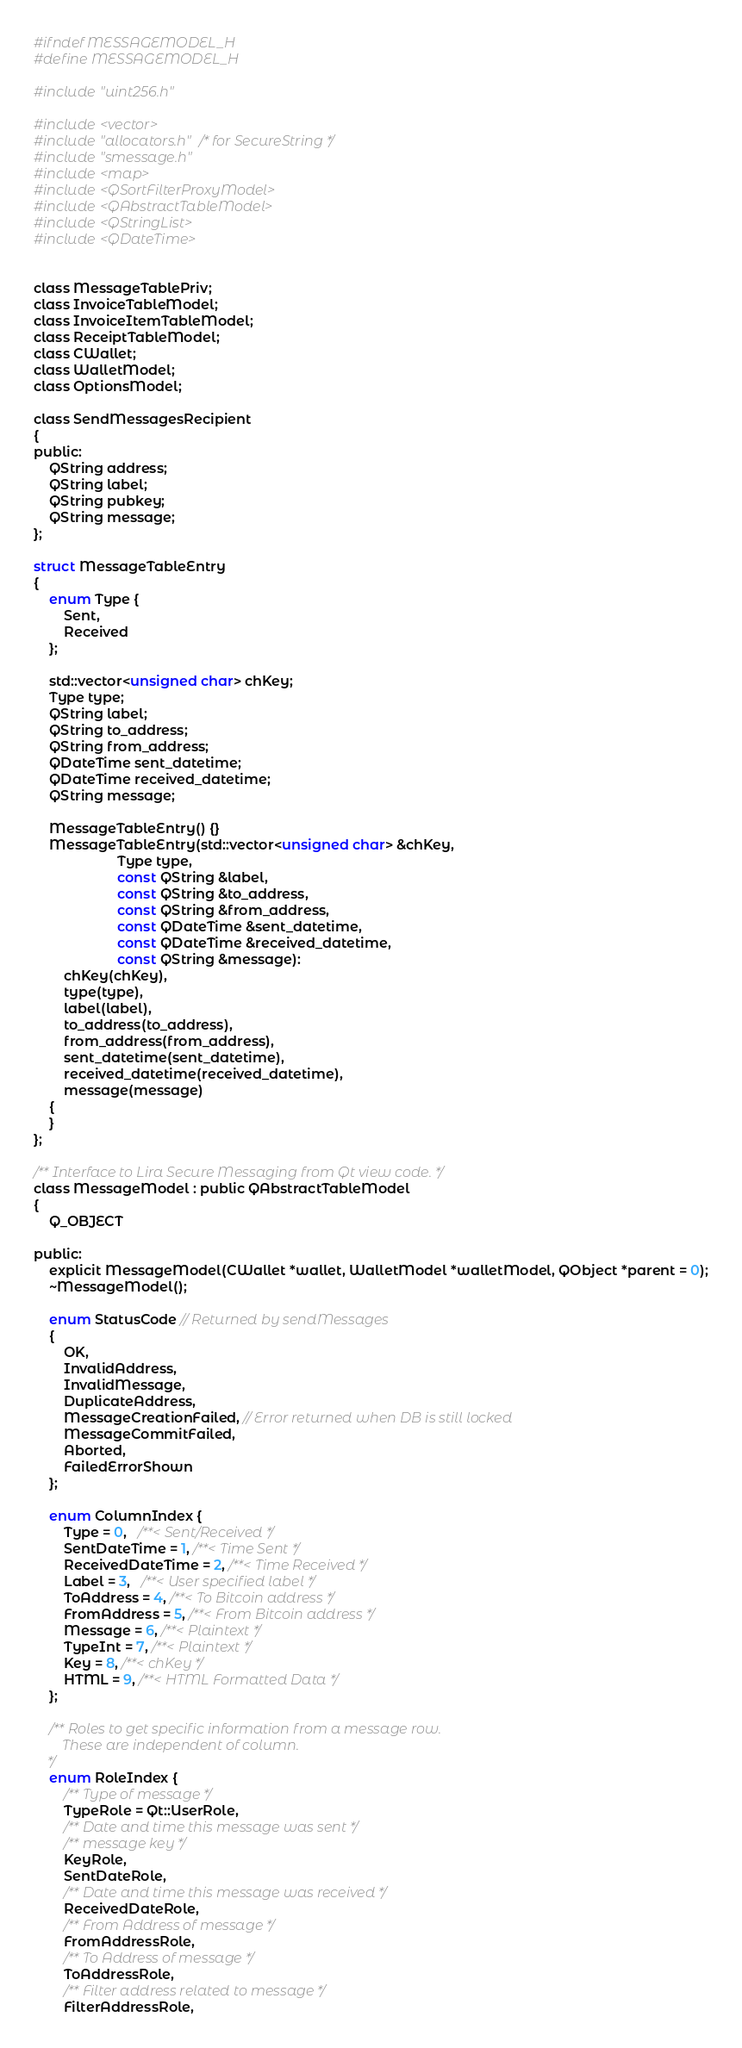Convert code to text. <code><loc_0><loc_0><loc_500><loc_500><_C_>#ifndef MESSAGEMODEL_H
#define MESSAGEMODEL_H

#include "uint256.h"

#include <vector>
#include "allocators.h" /* for SecureString */
#include "smessage.h"
#include <map>
#include <QSortFilterProxyModel>
#include <QAbstractTableModel>
#include <QStringList>
#include <QDateTime>


class MessageTablePriv;
class InvoiceTableModel;
class InvoiceItemTableModel;
class ReceiptTableModel;
class CWallet;
class WalletModel;
class OptionsModel;

class SendMessagesRecipient
{
public:
    QString address;
    QString label;
    QString pubkey;
    QString message;
};

struct MessageTableEntry
{
    enum Type {
        Sent,
        Received
    };
    
    std::vector<unsigned char> chKey;
    Type type;
    QString label;
    QString to_address;
    QString from_address;
    QDateTime sent_datetime;
    QDateTime received_datetime;
    QString message;

    MessageTableEntry() {}
    MessageTableEntry(std::vector<unsigned char> &chKey,
                      Type type,
                      const QString &label,
                      const QString &to_address,
                      const QString &from_address,
                      const QDateTime &sent_datetime,
                      const QDateTime &received_datetime,
                      const QString &message):
        chKey(chKey),
        type(type),
        label(label),
        to_address(to_address),
        from_address(from_address),
        sent_datetime(sent_datetime),
        received_datetime(received_datetime),
        message(message)
    {
    }
};

/** Interface to Lira Secure Messaging from Qt view code. */
class MessageModel : public QAbstractTableModel
{
    Q_OBJECT

public:
    explicit MessageModel(CWallet *wallet, WalletModel *walletModel, QObject *parent = 0);
    ~MessageModel();

    enum StatusCode // Returned by sendMessages
    {
        OK,
        InvalidAddress,
        InvalidMessage,
        DuplicateAddress,
        MessageCreationFailed, // Error returned when DB is still locked
        MessageCommitFailed,
        Aborted,
        FailedErrorShown
    };

    enum ColumnIndex {
        Type = 0,   /**< Sent/Received */
        SentDateTime = 1, /**< Time Sent */
        ReceivedDateTime = 2, /**< Time Received */
        Label = 3,   /**< User specified label */
        ToAddress = 4, /**< To Bitcoin address */
        FromAddress = 5, /**< From Bitcoin address */
        Message = 6, /**< Plaintext */
        TypeInt = 7, /**< Plaintext */
        Key = 8, /**< chKey */
        HTML = 9, /**< HTML Formatted Data */
    };

    /** Roles to get specific information from a message row.
        These are independent of column.
    */
    enum RoleIndex {
        /** Type of message */
        TypeRole = Qt::UserRole,
        /** Date and time this message was sent */
        /** message key */
        KeyRole,
        SentDateRole,
        /** Date and time this message was received */
        ReceivedDateRole,
        /** From Address of message */
        FromAddressRole,
        /** To Address of message */
        ToAddressRole,
        /** Filter address related to message */
        FilterAddressRole,</code> 